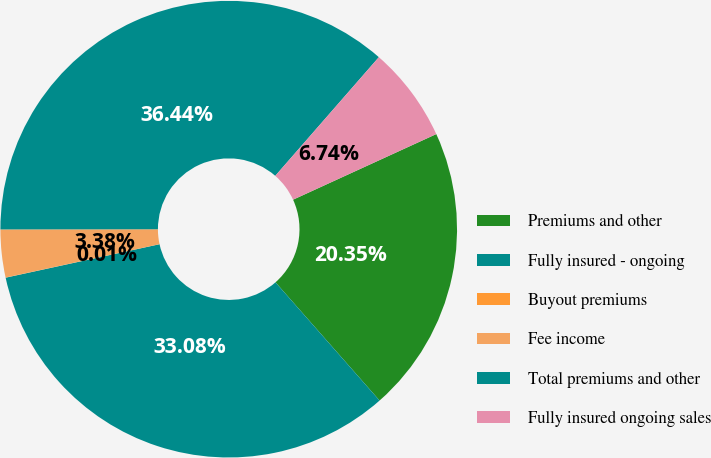<chart> <loc_0><loc_0><loc_500><loc_500><pie_chart><fcel>Premiums and other<fcel>Fully insured - ongoing<fcel>Buyout premiums<fcel>Fee income<fcel>Total premiums and other<fcel>Fully insured ongoing sales<nl><fcel>20.35%<fcel>33.08%<fcel>0.01%<fcel>3.38%<fcel>36.44%<fcel>6.74%<nl></chart> 